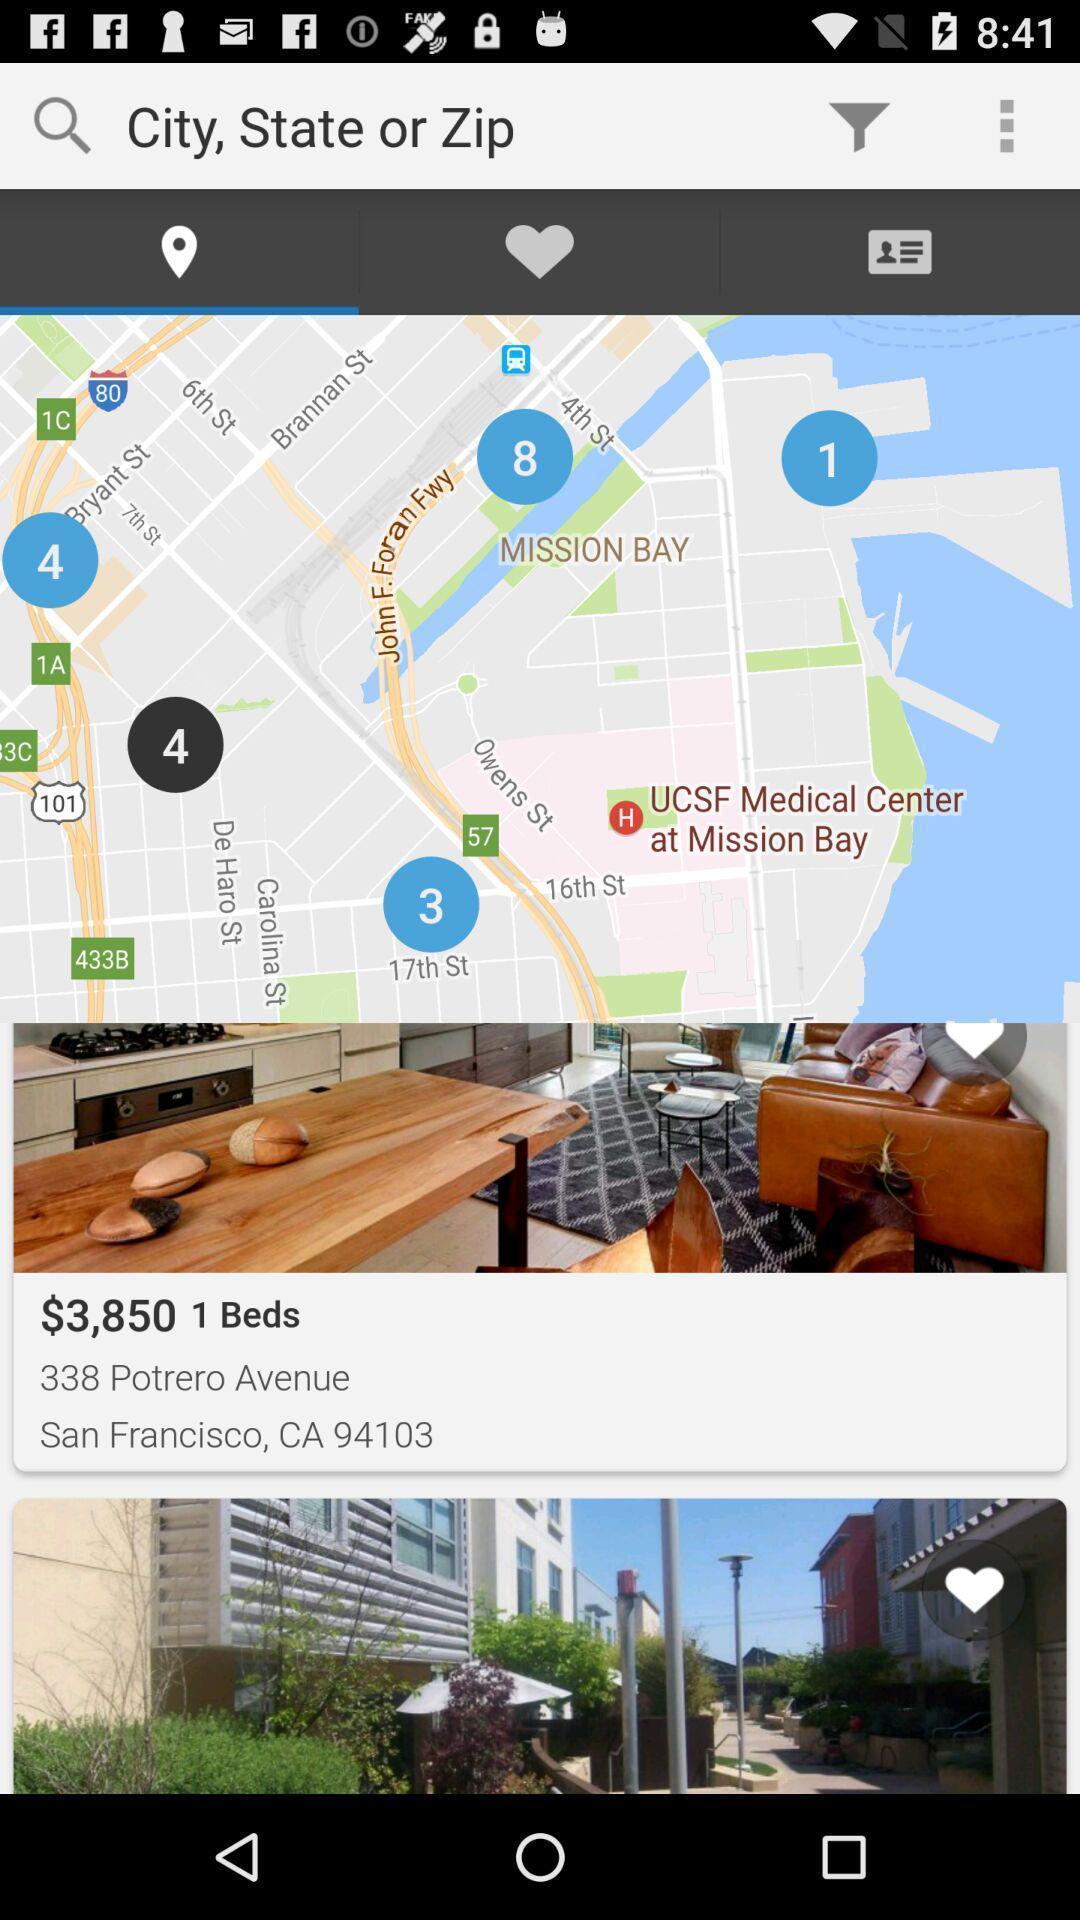What details can you identify in this image? Page displaying the multiple options an a applications. 